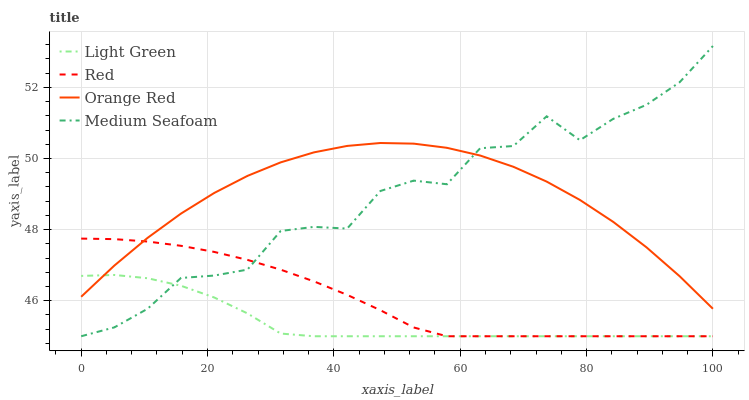Does Light Green have the minimum area under the curve?
Answer yes or no. Yes. Does Orange Red have the maximum area under the curve?
Answer yes or no. Yes. Does Red have the minimum area under the curve?
Answer yes or no. No. Does Red have the maximum area under the curve?
Answer yes or no. No. Is Red the smoothest?
Answer yes or no. Yes. Is Medium Seafoam the roughest?
Answer yes or no. Yes. Is Light Green the smoothest?
Answer yes or no. No. Is Light Green the roughest?
Answer yes or no. No. Does Medium Seafoam have the lowest value?
Answer yes or no. Yes. Does Orange Red have the lowest value?
Answer yes or no. No. Does Medium Seafoam have the highest value?
Answer yes or no. Yes. Does Red have the highest value?
Answer yes or no. No. Does Orange Red intersect Light Green?
Answer yes or no. Yes. Is Orange Red less than Light Green?
Answer yes or no. No. Is Orange Red greater than Light Green?
Answer yes or no. No. 